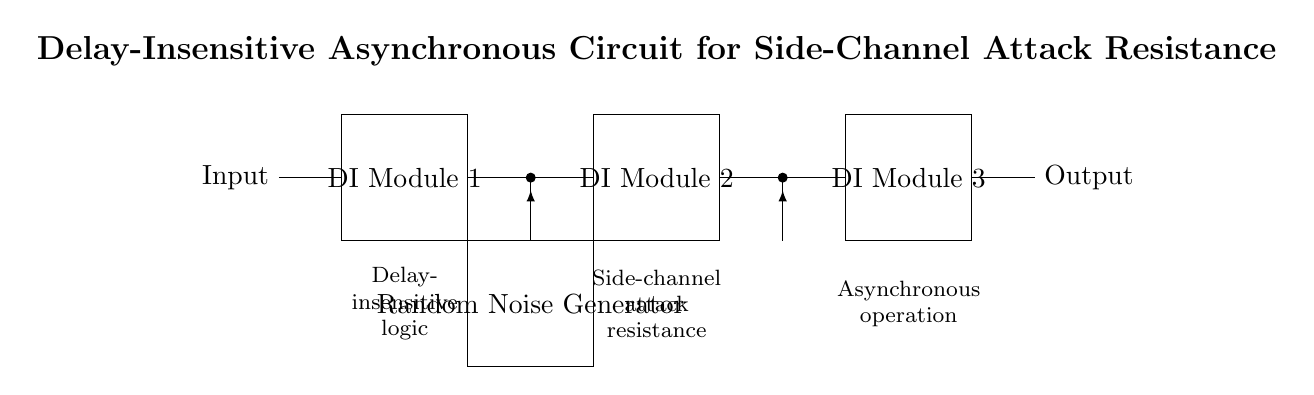What are the modules used in this circuit? The circuit includes three delay-insensitive (DI) modules labeled as DI Module 1, DI Module 2, and DI Module 3. Each of these modules contributes to the overall function of the circuit.
Answer: DI Module 1, DI Module 2, DI Module 3 What is the role of the random noise generator? The random noise generator is placed in the circuit to inject random noise into the signal paths, enhancing resistance against side-channel attacks by obfuscating the data processed by the modules.
Answer: Noise injection What type of logic is indicated in the circuit? The circuit is designed with delay-insensitive logic, which allows it to process signals independently of timing variations, making it beneficial for asynchronous operations.
Answer: Delay-insensitive logic How many noise injection points are there? There are two noise injection points in the circuit, indicated by two connections from the random noise generator to the two modules.
Answer: Two What type of operation does the circuit employ? The circuit operates asynchronously, meaning it does not rely on a global clock signal, allowing for more flexible processing and potentially better performance in side-channel attack scenarios.
Answer: Asynchronous operation Why is this circuit designed for side-channel attack resistance? The combination of delay-insensitive logic, noise injection, and the asynchronous nature of the circuit significantly complicates the ability of attackers to glean sensitive information from observable power or timing data.
Answer: Enhanced security What is the output of the circuit? The output is indicated as a single output connection that provides the processed signal after going through the delay-insensitive modules and noise injection.
Answer: Output 